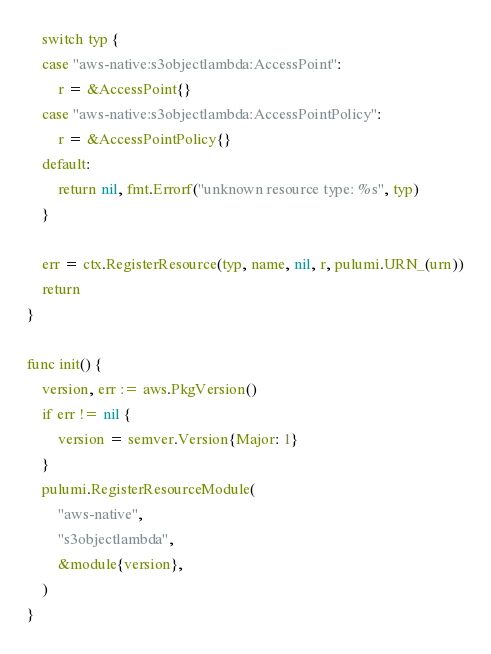Convert code to text. <code><loc_0><loc_0><loc_500><loc_500><_Go_>	switch typ {
	case "aws-native:s3objectlambda:AccessPoint":
		r = &AccessPoint{}
	case "aws-native:s3objectlambda:AccessPointPolicy":
		r = &AccessPointPolicy{}
	default:
		return nil, fmt.Errorf("unknown resource type: %s", typ)
	}

	err = ctx.RegisterResource(typ, name, nil, r, pulumi.URN_(urn))
	return
}

func init() {
	version, err := aws.PkgVersion()
	if err != nil {
		version = semver.Version{Major: 1}
	}
	pulumi.RegisterResourceModule(
		"aws-native",
		"s3objectlambda",
		&module{version},
	)
}
</code> 